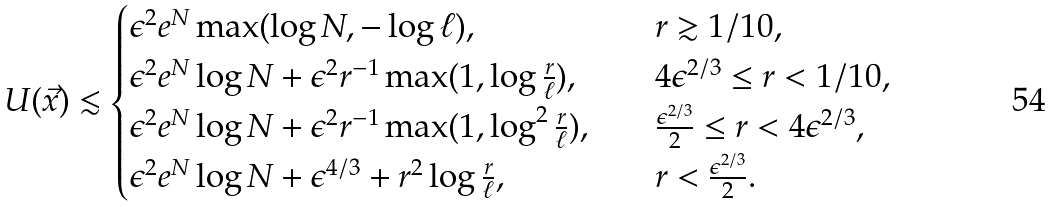<formula> <loc_0><loc_0><loc_500><loc_500>U ( \vec { x } ) \lesssim \begin{cases} \epsilon ^ { 2 } e ^ { N } \max ( \log N , - \log \ell ) , \quad & r \gtrsim 1 / 1 0 , \\ \epsilon ^ { 2 } e ^ { N } \log N + \epsilon ^ { 2 } r ^ { - 1 } \max ( 1 , \log \frac { r } { \ell } ) , \quad & 4 \epsilon ^ { 2 / 3 } \leq r < 1 / 1 0 , \\ \epsilon ^ { 2 } e ^ { N } \log N + \epsilon ^ { 2 } r ^ { - 1 } \max ( 1 , \log ^ { 2 } \frac { r } { \ell } ) , \quad & \frac { \epsilon ^ { 2 / 3 } } { 2 } \leq r < 4 \epsilon ^ { 2 / 3 } , \\ \epsilon ^ { 2 } e ^ { N } \log N + \epsilon ^ { 4 / 3 } + r ^ { 2 } \log \frac { r } { \ell } , \quad & r < \frac { \epsilon ^ { 2 / 3 } } { 2 } . \end{cases}</formula> 